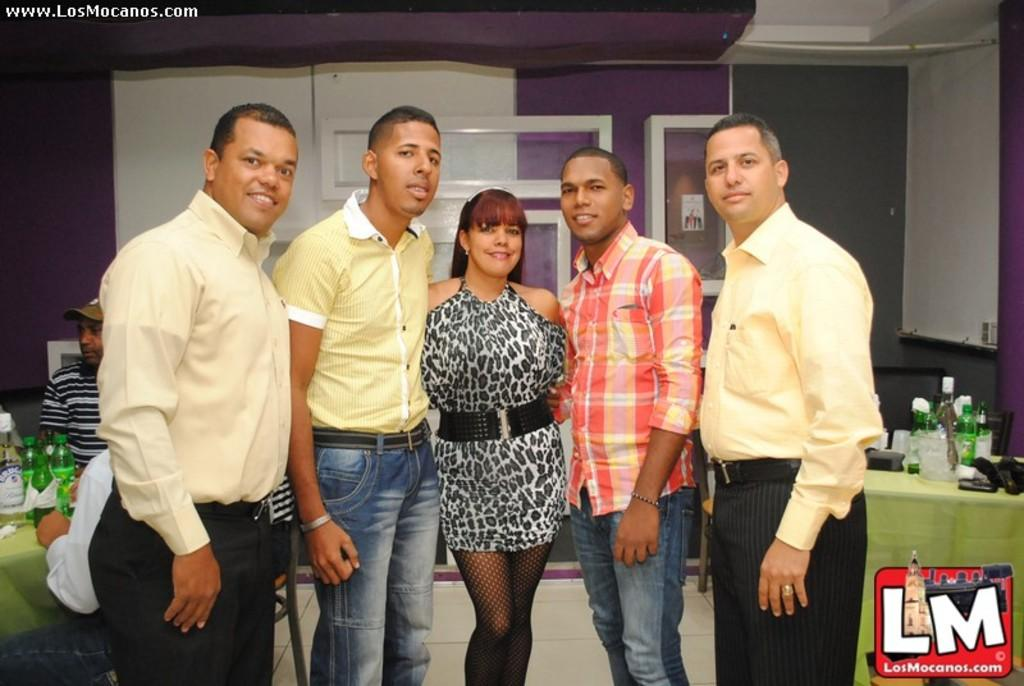What are the people in the image doing? There are people standing and sitting in the image. What can be seen on the tables in the image? Objects are placed on the tables in the image. How many tables are visible in the image? The number of tables cannot be determined from the provided facts. What type of gold object is placed on the shelf in the image? There is no shelf or gold object present in the image. 